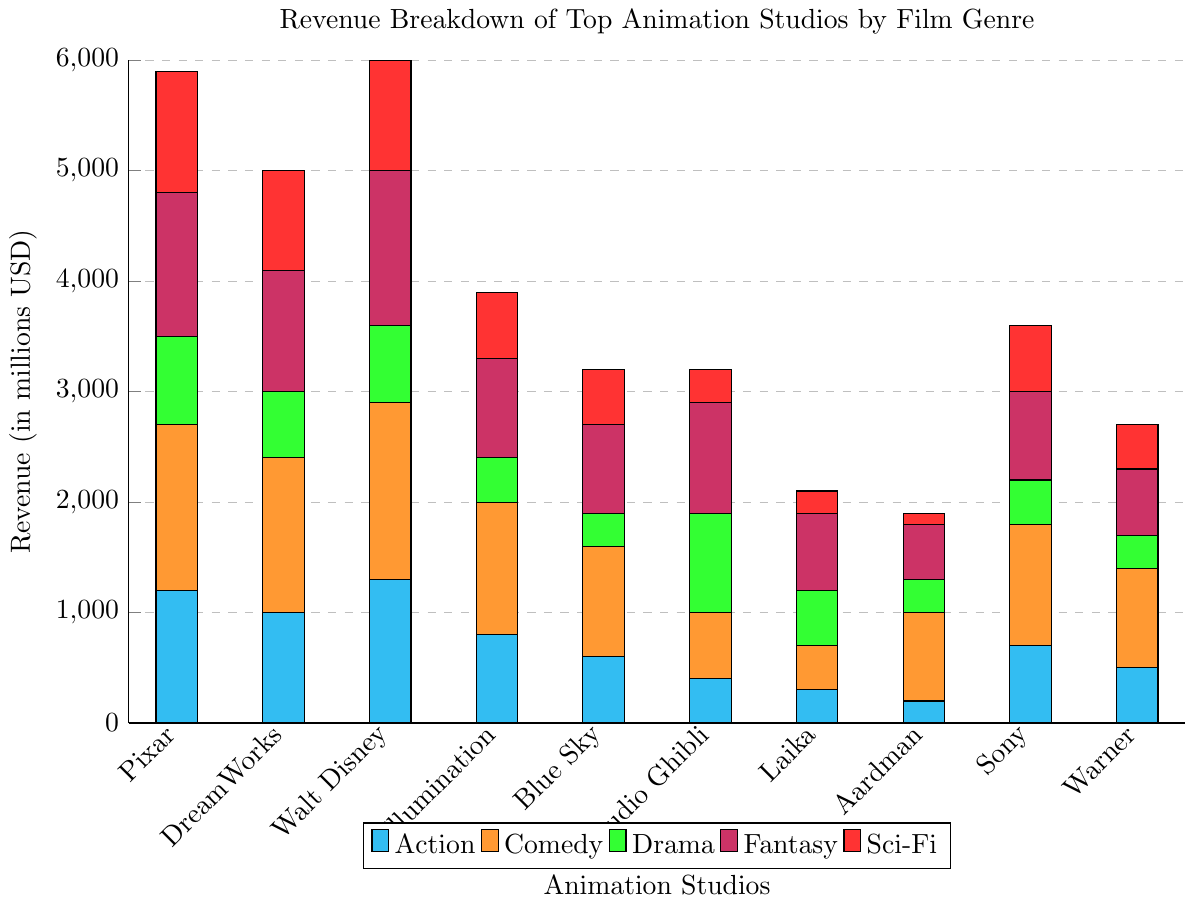Which studio has the highest total revenue across all genres? To find the total revenue, sum the revenue for each genre for each studio. Pixar has the highest total with 1200 + 1500 + 800 + 1300 + 1100 = 5900.
Answer: Pixar What is the combined revenue for Pixar and Walt Disney Animation in the Sci-Fi genre? Adding the Sci-Fi revenue for Pixar and Walt Disney Animation: 1100 (Pixar) + 1000 (Walt Disney Animation) = 2100.
Answer: 2100 Which genre contributes the least revenue to Aardman Animations? From the chart, the genre with the smallest bar for Aardman Animations is Sci-Fi with a revenue of 100.
Answer: Sci-Fi What is the percentage difference in Comedy revenue between DreamWorks and Illumination Entertainment? The Comedy revenue for DreamWorks is 1400 and for Illumination Entertainment is 1200. The percentage difference is computed as ((1400 - 1200) / 1400) * 100 = (200 / 1400) * 100 ≈ 14.29%.
Answer: 14.29% Which studio has earned more revenue in Drama, Studio Ghibli or Illumination Entertainment, and by how much? The Drama revenue for Studio Ghibli is 900 and for Illumination Entertainment is 400. The difference is 900 - 400 = 500.
Answer: Studio Ghibli, 500 How does the total revenue for Laika compare to the total revenue for Blue Sky Studios? Summing the total revenue for Laika (300 + 400 + 500 + 700 + 200 = 2100) and Blue Sky Studios (600 + 1000 + 300 + 800 + 500 = 3200), Blue Sky Studios has more revenue.
Answer: Blue Sky Studios Which studio has the highest revenue in the Action genre and how much more is it compared to the studio with the lowest revenue in the same genre? The highest revenue in the Action genre is Walt Disney Animation with 1300, and the lowest is Aardman Animations with 200. The difference is 1300 - 200 = 1100.
Answer: Walt Disney Animation, 1100 What is the average revenue for the Fantasy genre across all studios? Sum the Fantasy revenue for all studios (1300 + 1100 + 1400 + 900 + 800 + 1000 + 700 + 500 + 800 + 600 = 9100) and divide by the number of studios (9100 / 10 = 910).
Answer: 910 Which two studios have equal revenue in the Drama genre? Both Illumination Entertainment and Sony Pictures Animation have a Drama revenue of 400.
Answer: Illumination Entertainment, Sony Pictures Animation What is the difference in the total revenue between Pixar and DreamWorks? The total revenue for Pixar is 5900 and for DreamWorks is 5000. The difference is 5900 - 5000 = 900.
Answer: 900 